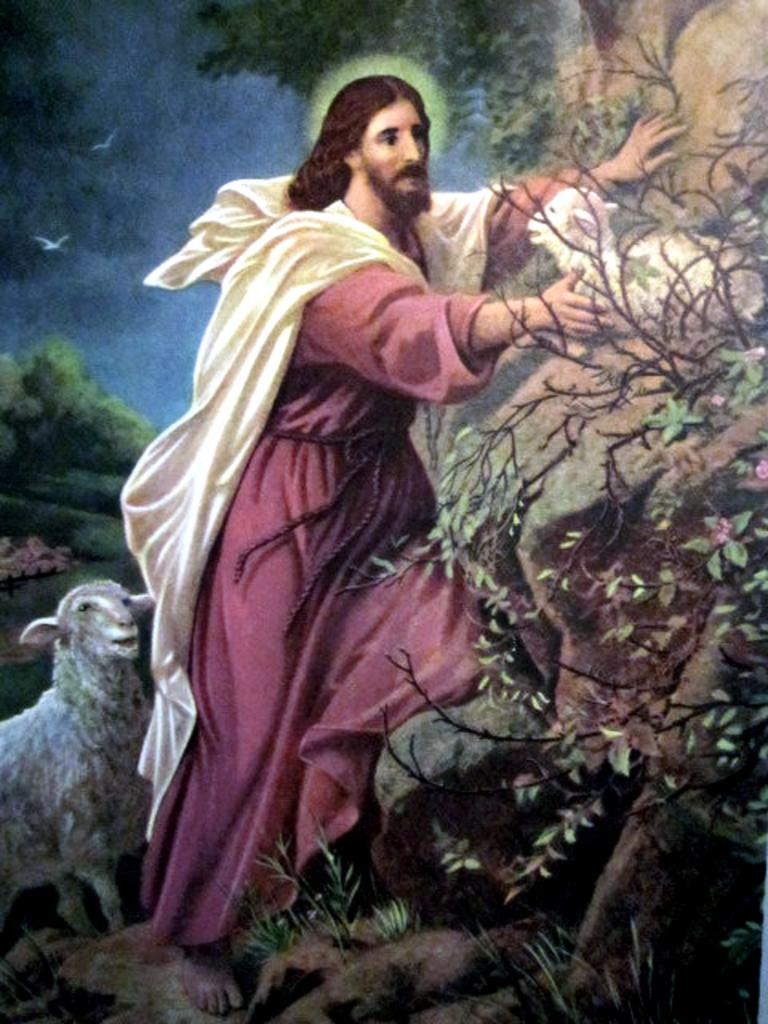What is the person in the image standing beside? The person is standing beside a rock in the image. What type of animals can be seen in the image? There are birds and sheep visible in the image. What type of vegetation is present in the image? There are trees in the image. What other elements can be seen in the image? There are other unspecified elements in the image. How much rain is falling in the image? There is no rain visible in the image. What type of bird can be seen in the image? The provided facts do not specify the type of bird; only that there are birds visible in the image. 